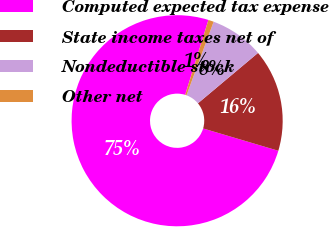Convert chart to OTSL. <chart><loc_0><loc_0><loc_500><loc_500><pie_chart><fcel>Computed expected tax expense<fcel>State income taxes net of<fcel>Nondeductible stock<fcel>Other net<nl><fcel>75.2%<fcel>15.7%<fcel>8.27%<fcel>0.83%<nl></chart> 